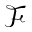Convert formula to latex. <formula><loc_0><loc_0><loc_500><loc_500>\mathcal { F }</formula> 